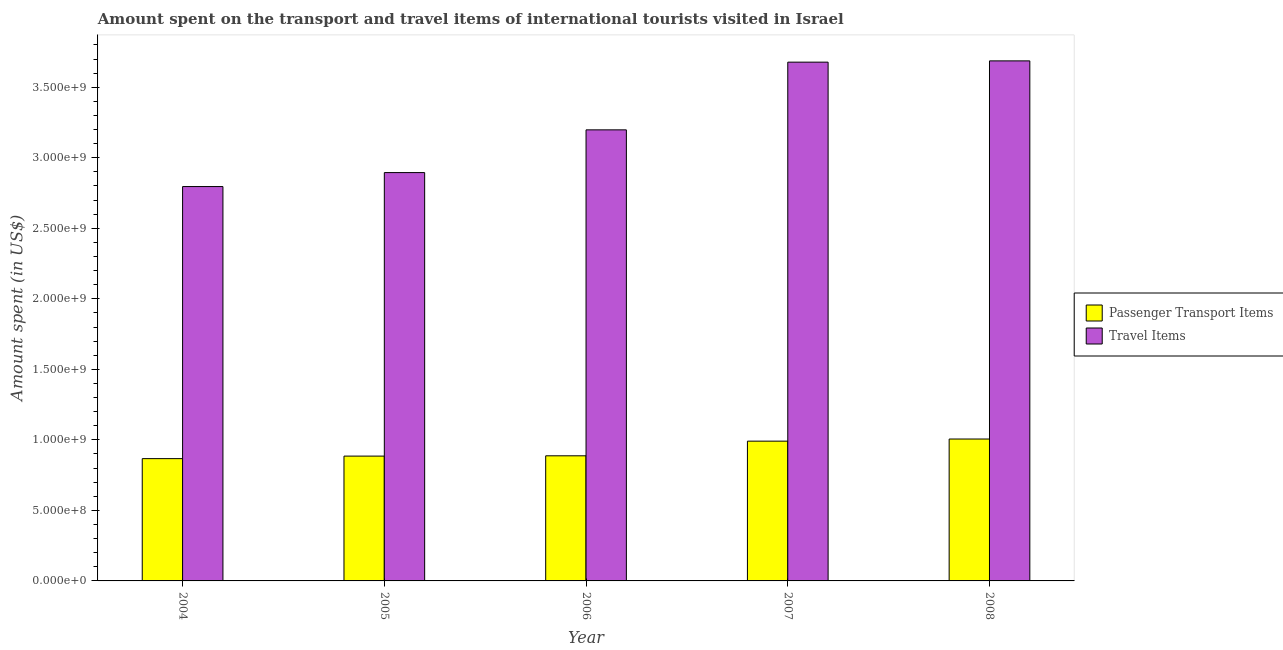How many different coloured bars are there?
Offer a terse response. 2. How many groups of bars are there?
Make the answer very short. 5. How many bars are there on the 3rd tick from the left?
Provide a succinct answer. 2. How many bars are there on the 3rd tick from the right?
Provide a succinct answer. 2. What is the amount spent in travel items in 2006?
Make the answer very short. 3.20e+09. Across all years, what is the maximum amount spent on passenger transport items?
Ensure brevity in your answer.  1.01e+09. Across all years, what is the minimum amount spent on passenger transport items?
Give a very brief answer. 8.67e+08. In which year was the amount spent on passenger transport items maximum?
Give a very brief answer. 2008. What is the total amount spent on passenger transport items in the graph?
Your answer should be compact. 4.64e+09. What is the difference between the amount spent in travel items in 2005 and that in 2006?
Give a very brief answer. -3.03e+08. What is the difference between the amount spent in travel items in 2005 and the amount spent on passenger transport items in 2006?
Make the answer very short. -3.03e+08. What is the average amount spent in travel items per year?
Provide a succinct answer. 3.25e+09. What is the ratio of the amount spent on passenger transport items in 2005 to that in 2006?
Your answer should be compact. 1. Is the amount spent on passenger transport items in 2006 less than that in 2008?
Your response must be concise. Yes. What is the difference between the highest and the second highest amount spent on passenger transport items?
Provide a succinct answer. 1.50e+07. What is the difference between the highest and the lowest amount spent on passenger transport items?
Ensure brevity in your answer.  1.39e+08. Is the sum of the amount spent on passenger transport items in 2006 and 2008 greater than the maximum amount spent in travel items across all years?
Provide a short and direct response. Yes. What does the 2nd bar from the left in 2005 represents?
Give a very brief answer. Travel Items. What does the 2nd bar from the right in 2008 represents?
Your response must be concise. Passenger Transport Items. How many bars are there?
Offer a terse response. 10. Are all the bars in the graph horizontal?
Your answer should be compact. No. How many years are there in the graph?
Offer a very short reply. 5. What is the difference between two consecutive major ticks on the Y-axis?
Your answer should be very brief. 5.00e+08. What is the title of the graph?
Keep it short and to the point. Amount spent on the transport and travel items of international tourists visited in Israel. Does "Malaria" appear as one of the legend labels in the graph?
Make the answer very short. No. What is the label or title of the Y-axis?
Give a very brief answer. Amount spent (in US$). What is the Amount spent (in US$) in Passenger Transport Items in 2004?
Provide a short and direct response. 8.67e+08. What is the Amount spent (in US$) in Travel Items in 2004?
Give a very brief answer. 2.80e+09. What is the Amount spent (in US$) of Passenger Transport Items in 2005?
Your response must be concise. 8.85e+08. What is the Amount spent (in US$) in Travel Items in 2005?
Keep it short and to the point. 2.90e+09. What is the Amount spent (in US$) in Passenger Transport Items in 2006?
Your answer should be very brief. 8.87e+08. What is the Amount spent (in US$) of Travel Items in 2006?
Offer a terse response. 3.20e+09. What is the Amount spent (in US$) in Passenger Transport Items in 2007?
Provide a short and direct response. 9.91e+08. What is the Amount spent (in US$) of Travel Items in 2007?
Your response must be concise. 3.68e+09. What is the Amount spent (in US$) in Passenger Transport Items in 2008?
Provide a succinct answer. 1.01e+09. What is the Amount spent (in US$) in Travel Items in 2008?
Provide a short and direct response. 3.69e+09. Across all years, what is the maximum Amount spent (in US$) in Passenger Transport Items?
Ensure brevity in your answer.  1.01e+09. Across all years, what is the maximum Amount spent (in US$) of Travel Items?
Your response must be concise. 3.69e+09. Across all years, what is the minimum Amount spent (in US$) in Passenger Transport Items?
Your answer should be compact. 8.67e+08. Across all years, what is the minimum Amount spent (in US$) of Travel Items?
Ensure brevity in your answer.  2.80e+09. What is the total Amount spent (in US$) of Passenger Transport Items in the graph?
Provide a succinct answer. 4.64e+09. What is the total Amount spent (in US$) of Travel Items in the graph?
Your answer should be very brief. 1.63e+1. What is the difference between the Amount spent (in US$) of Passenger Transport Items in 2004 and that in 2005?
Your answer should be compact. -1.80e+07. What is the difference between the Amount spent (in US$) in Travel Items in 2004 and that in 2005?
Offer a very short reply. -9.90e+07. What is the difference between the Amount spent (in US$) in Passenger Transport Items in 2004 and that in 2006?
Offer a very short reply. -2.00e+07. What is the difference between the Amount spent (in US$) in Travel Items in 2004 and that in 2006?
Your answer should be compact. -4.02e+08. What is the difference between the Amount spent (in US$) of Passenger Transport Items in 2004 and that in 2007?
Your answer should be very brief. -1.24e+08. What is the difference between the Amount spent (in US$) in Travel Items in 2004 and that in 2007?
Provide a succinct answer. -8.82e+08. What is the difference between the Amount spent (in US$) of Passenger Transport Items in 2004 and that in 2008?
Your answer should be very brief. -1.39e+08. What is the difference between the Amount spent (in US$) in Travel Items in 2004 and that in 2008?
Offer a very short reply. -8.91e+08. What is the difference between the Amount spent (in US$) in Travel Items in 2005 and that in 2006?
Your answer should be compact. -3.03e+08. What is the difference between the Amount spent (in US$) in Passenger Transport Items in 2005 and that in 2007?
Your response must be concise. -1.06e+08. What is the difference between the Amount spent (in US$) in Travel Items in 2005 and that in 2007?
Provide a short and direct response. -7.83e+08. What is the difference between the Amount spent (in US$) of Passenger Transport Items in 2005 and that in 2008?
Ensure brevity in your answer.  -1.21e+08. What is the difference between the Amount spent (in US$) of Travel Items in 2005 and that in 2008?
Keep it short and to the point. -7.92e+08. What is the difference between the Amount spent (in US$) in Passenger Transport Items in 2006 and that in 2007?
Provide a short and direct response. -1.04e+08. What is the difference between the Amount spent (in US$) of Travel Items in 2006 and that in 2007?
Keep it short and to the point. -4.80e+08. What is the difference between the Amount spent (in US$) of Passenger Transport Items in 2006 and that in 2008?
Your response must be concise. -1.19e+08. What is the difference between the Amount spent (in US$) of Travel Items in 2006 and that in 2008?
Ensure brevity in your answer.  -4.89e+08. What is the difference between the Amount spent (in US$) of Passenger Transport Items in 2007 and that in 2008?
Provide a short and direct response. -1.50e+07. What is the difference between the Amount spent (in US$) in Travel Items in 2007 and that in 2008?
Make the answer very short. -9.00e+06. What is the difference between the Amount spent (in US$) of Passenger Transport Items in 2004 and the Amount spent (in US$) of Travel Items in 2005?
Your answer should be compact. -2.03e+09. What is the difference between the Amount spent (in US$) in Passenger Transport Items in 2004 and the Amount spent (in US$) in Travel Items in 2006?
Provide a short and direct response. -2.33e+09. What is the difference between the Amount spent (in US$) of Passenger Transport Items in 2004 and the Amount spent (in US$) of Travel Items in 2007?
Your answer should be compact. -2.81e+09. What is the difference between the Amount spent (in US$) in Passenger Transport Items in 2004 and the Amount spent (in US$) in Travel Items in 2008?
Give a very brief answer. -2.82e+09. What is the difference between the Amount spent (in US$) in Passenger Transport Items in 2005 and the Amount spent (in US$) in Travel Items in 2006?
Give a very brief answer. -2.31e+09. What is the difference between the Amount spent (in US$) in Passenger Transport Items in 2005 and the Amount spent (in US$) in Travel Items in 2007?
Offer a terse response. -2.79e+09. What is the difference between the Amount spent (in US$) of Passenger Transport Items in 2005 and the Amount spent (in US$) of Travel Items in 2008?
Ensure brevity in your answer.  -2.80e+09. What is the difference between the Amount spent (in US$) of Passenger Transport Items in 2006 and the Amount spent (in US$) of Travel Items in 2007?
Provide a short and direct response. -2.79e+09. What is the difference between the Amount spent (in US$) of Passenger Transport Items in 2006 and the Amount spent (in US$) of Travel Items in 2008?
Ensure brevity in your answer.  -2.80e+09. What is the difference between the Amount spent (in US$) in Passenger Transport Items in 2007 and the Amount spent (in US$) in Travel Items in 2008?
Offer a very short reply. -2.70e+09. What is the average Amount spent (in US$) in Passenger Transport Items per year?
Give a very brief answer. 9.27e+08. What is the average Amount spent (in US$) of Travel Items per year?
Offer a terse response. 3.25e+09. In the year 2004, what is the difference between the Amount spent (in US$) of Passenger Transport Items and Amount spent (in US$) of Travel Items?
Give a very brief answer. -1.93e+09. In the year 2005, what is the difference between the Amount spent (in US$) of Passenger Transport Items and Amount spent (in US$) of Travel Items?
Provide a short and direct response. -2.01e+09. In the year 2006, what is the difference between the Amount spent (in US$) of Passenger Transport Items and Amount spent (in US$) of Travel Items?
Your response must be concise. -2.31e+09. In the year 2007, what is the difference between the Amount spent (in US$) of Passenger Transport Items and Amount spent (in US$) of Travel Items?
Provide a short and direct response. -2.69e+09. In the year 2008, what is the difference between the Amount spent (in US$) in Passenger Transport Items and Amount spent (in US$) in Travel Items?
Make the answer very short. -2.68e+09. What is the ratio of the Amount spent (in US$) of Passenger Transport Items in 2004 to that in 2005?
Offer a very short reply. 0.98. What is the ratio of the Amount spent (in US$) in Travel Items in 2004 to that in 2005?
Give a very brief answer. 0.97. What is the ratio of the Amount spent (in US$) of Passenger Transport Items in 2004 to that in 2006?
Keep it short and to the point. 0.98. What is the ratio of the Amount spent (in US$) of Travel Items in 2004 to that in 2006?
Your answer should be very brief. 0.87. What is the ratio of the Amount spent (in US$) of Passenger Transport Items in 2004 to that in 2007?
Your response must be concise. 0.87. What is the ratio of the Amount spent (in US$) of Travel Items in 2004 to that in 2007?
Provide a succinct answer. 0.76. What is the ratio of the Amount spent (in US$) in Passenger Transport Items in 2004 to that in 2008?
Make the answer very short. 0.86. What is the ratio of the Amount spent (in US$) in Travel Items in 2004 to that in 2008?
Offer a very short reply. 0.76. What is the ratio of the Amount spent (in US$) of Passenger Transport Items in 2005 to that in 2006?
Make the answer very short. 1. What is the ratio of the Amount spent (in US$) of Travel Items in 2005 to that in 2006?
Offer a terse response. 0.91. What is the ratio of the Amount spent (in US$) of Passenger Transport Items in 2005 to that in 2007?
Keep it short and to the point. 0.89. What is the ratio of the Amount spent (in US$) of Travel Items in 2005 to that in 2007?
Provide a short and direct response. 0.79. What is the ratio of the Amount spent (in US$) in Passenger Transport Items in 2005 to that in 2008?
Keep it short and to the point. 0.88. What is the ratio of the Amount spent (in US$) in Travel Items in 2005 to that in 2008?
Keep it short and to the point. 0.79. What is the ratio of the Amount spent (in US$) in Passenger Transport Items in 2006 to that in 2007?
Provide a short and direct response. 0.9. What is the ratio of the Amount spent (in US$) in Travel Items in 2006 to that in 2007?
Your response must be concise. 0.87. What is the ratio of the Amount spent (in US$) in Passenger Transport Items in 2006 to that in 2008?
Your answer should be very brief. 0.88. What is the ratio of the Amount spent (in US$) in Travel Items in 2006 to that in 2008?
Your response must be concise. 0.87. What is the ratio of the Amount spent (in US$) of Passenger Transport Items in 2007 to that in 2008?
Keep it short and to the point. 0.99. What is the ratio of the Amount spent (in US$) of Travel Items in 2007 to that in 2008?
Provide a short and direct response. 1. What is the difference between the highest and the second highest Amount spent (in US$) of Passenger Transport Items?
Ensure brevity in your answer.  1.50e+07. What is the difference between the highest and the second highest Amount spent (in US$) of Travel Items?
Offer a very short reply. 9.00e+06. What is the difference between the highest and the lowest Amount spent (in US$) in Passenger Transport Items?
Keep it short and to the point. 1.39e+08. What is the difference between the highest and the lowest Amount spent (in US$) in Travel Items?
Your answer should be compact. 8.91e+08. 